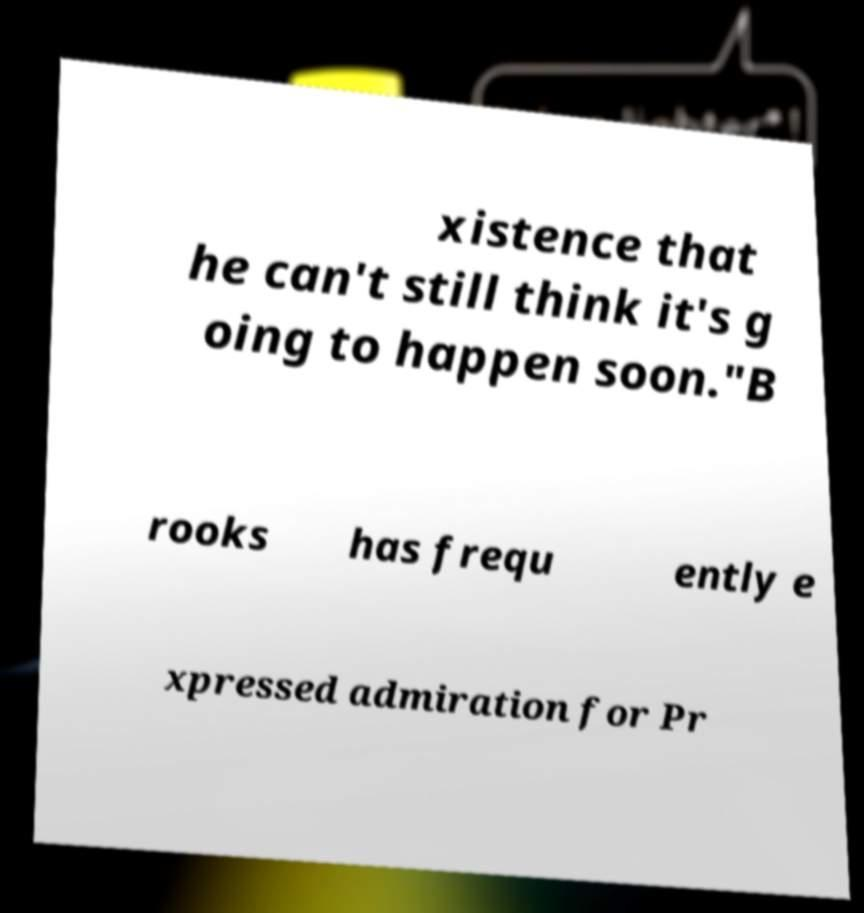Could you extract and type out the text from this image? xistence that he can't still think it's g oing to happen soon."B rooks has frequ ently e xpressed admiration for Pr 